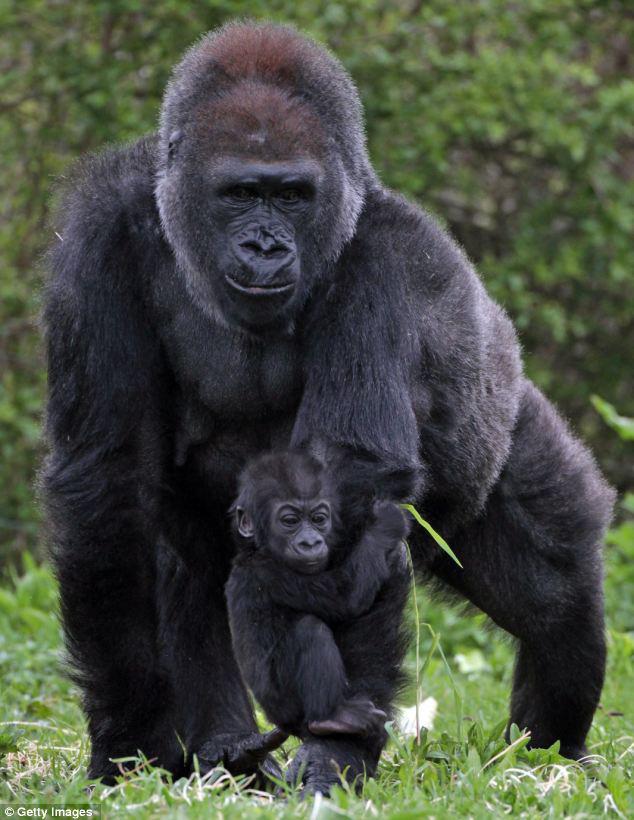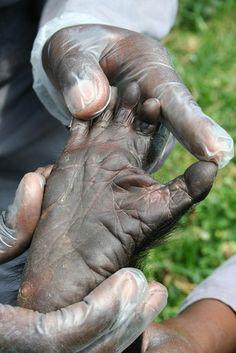The first image is the image on the left, the second image is the image on the right. Analyze the images presented: Is the assertion "A mother gorilla is holding her infant on one arm" valid? Answer yes or no. Yes. The first image is the image on the left, the second image is the image on the right. Assess this claim about the two images: "The left image shows a baby gorilla clinging to the arm of an adult gorilla, and the right image includes a hand touching a foot.". Correct or not? Answer yes or no. Yes. 